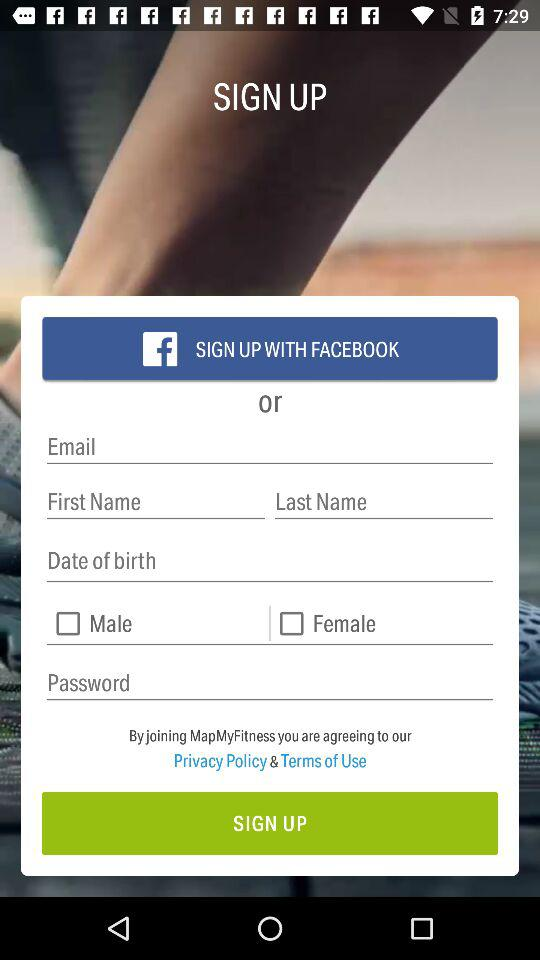What applications are used for sign-up? The application is "Facebook". 